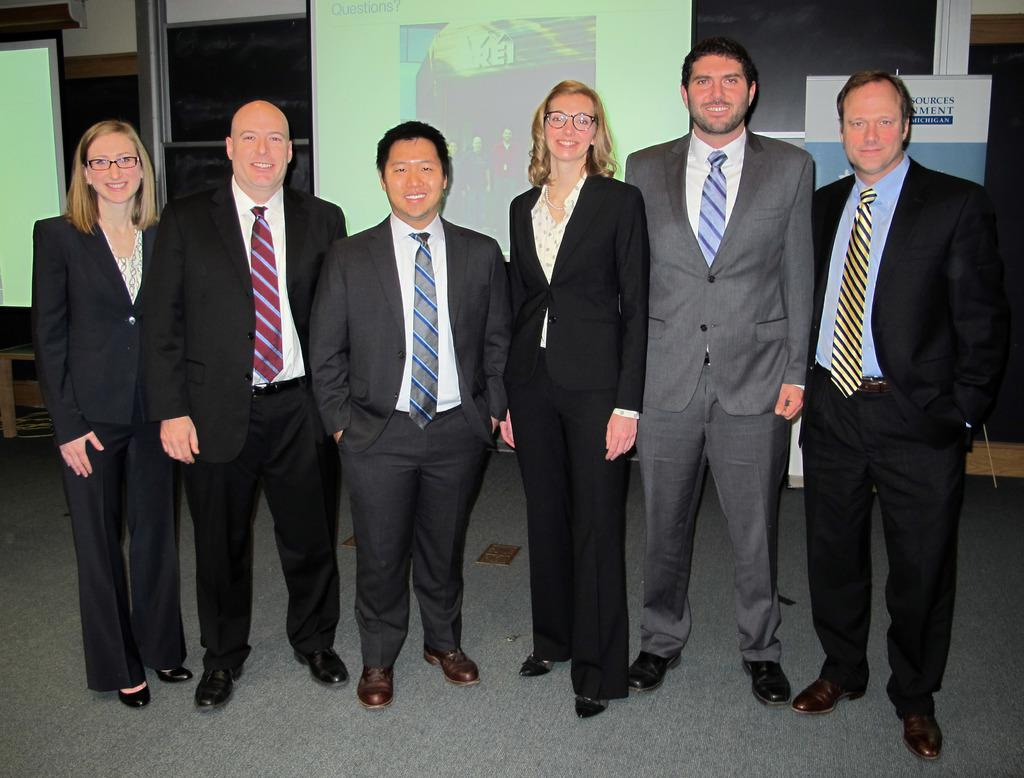How many people are in the group in the image? There is a group of people in the image, but the exact number is not specified. What is the facial expression of some people in the group? Some people in the group are smiling. What can be seen in the background of the image? There are projector screens and a hoarding visible in the background. Can you hear the frogs talking to each other in the image? There are no frogs present in the image, so it is not possible to hear them talking. 